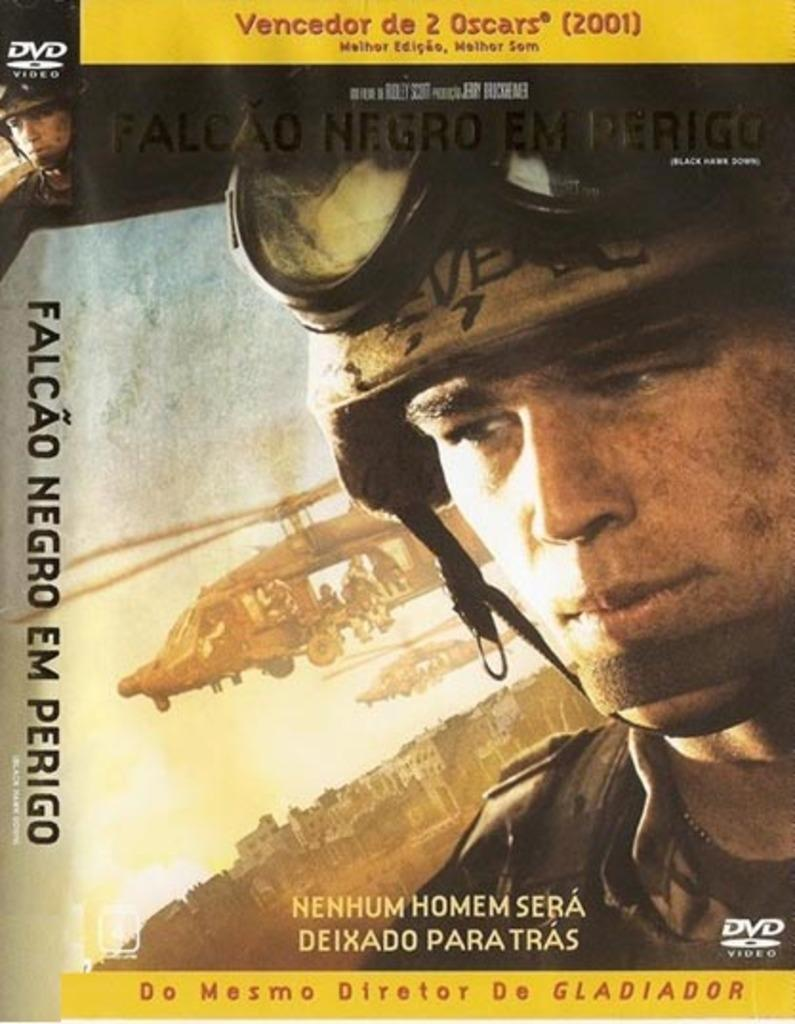<image>
Relay a brief, clear account of the picture shown. a dvd that has been nomincated for 2 oscars 